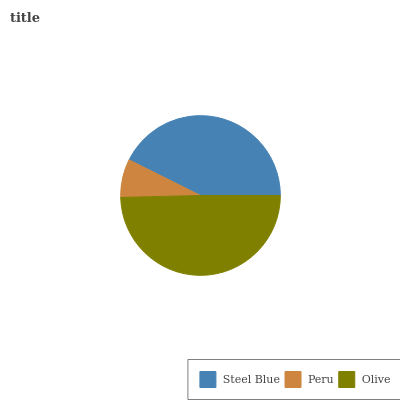Is Peru the minimum?
Answer yes or no. Yes. Is Olive the maximum?
Answer yes or no. Yes. Is Olive the minimum?
Answer yes or no. No. Is Peru the maximum?
Answer yes or no. No. Is Olive greater than Peru?
Answer yes or no. Yes. Is Peru less than Olive?
Answer yes or no. Yes. Is Peru greater than Olive?
Answer yes or no. No. Is Olive less than Peru?
Answer yes or no. No. Is Steel Blue the high median?
Answer yes or no. Yes. Is Steel Blue the low median?
Answer yes or no. Yes. Is Olive the high median?
Answer yes or no. No. Is Peru the low median?
Answer yes or no. No. 